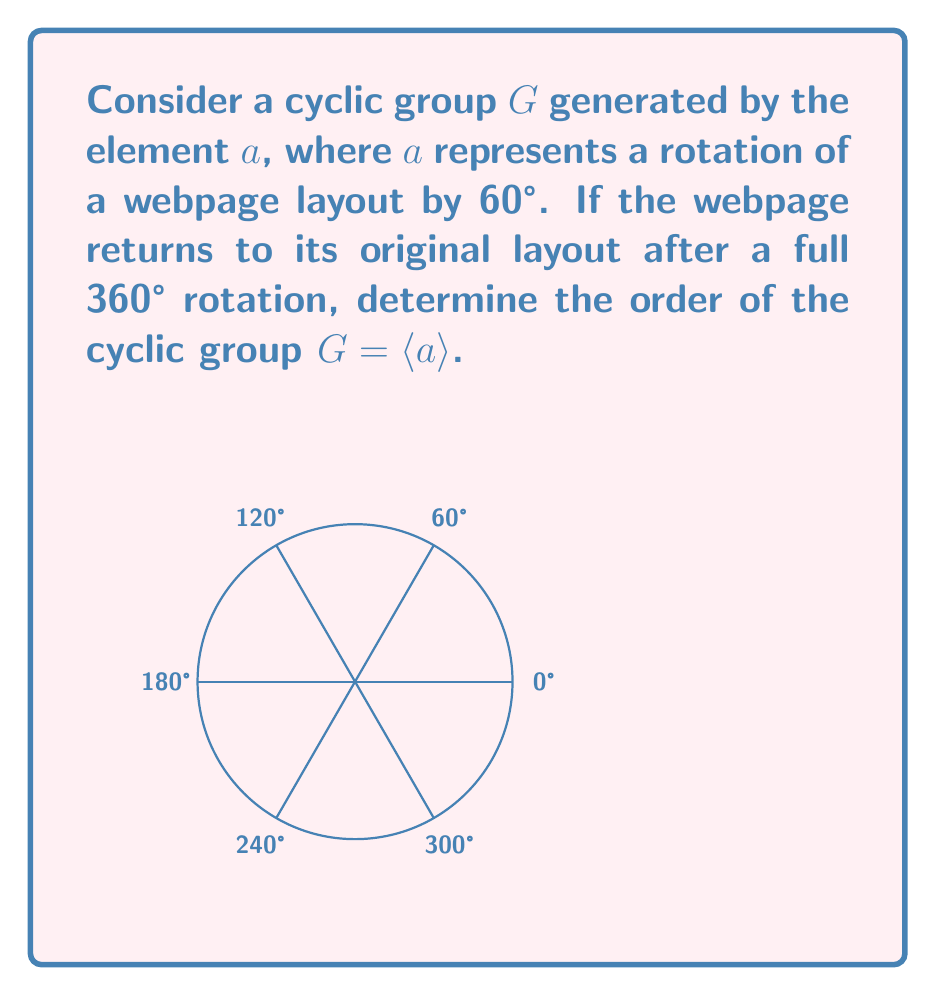Can you answer this question? To determine the order of the cyclic group $G = \langle a \rangle$, we need to find the smallest positive integer $n$ such that $a^n = e$, where $e$ is the identity element.

1) Each application of $a$ rotates the webpage by 60°.

2) We need to find how many rotations of 60° are required to complete a full 360° rotation:

   $$360° \div 60° = 6$$

3) This means that $a^6 = e$, as six 60° rotations bring the webpage back to its original layout.

4) We can verify that no smaller positive integer $k < 6$ satisfies $a^k = e$:
   - $a^1$: 60° rotation
   - $a^2$: 120° rotation
   - $a^3$: 180° rotation
   - $a^4$: 240° rotation
   - $a^5$: 300° rotation

5) Therefore, the smallest positive integer $n$ such that $a^n = e$ is 6.

6) By definition, the order of the cyclic group $G = \langle a \rangle$ is equal to the order of the generating element $a$, which is 6.
Answer: 6 